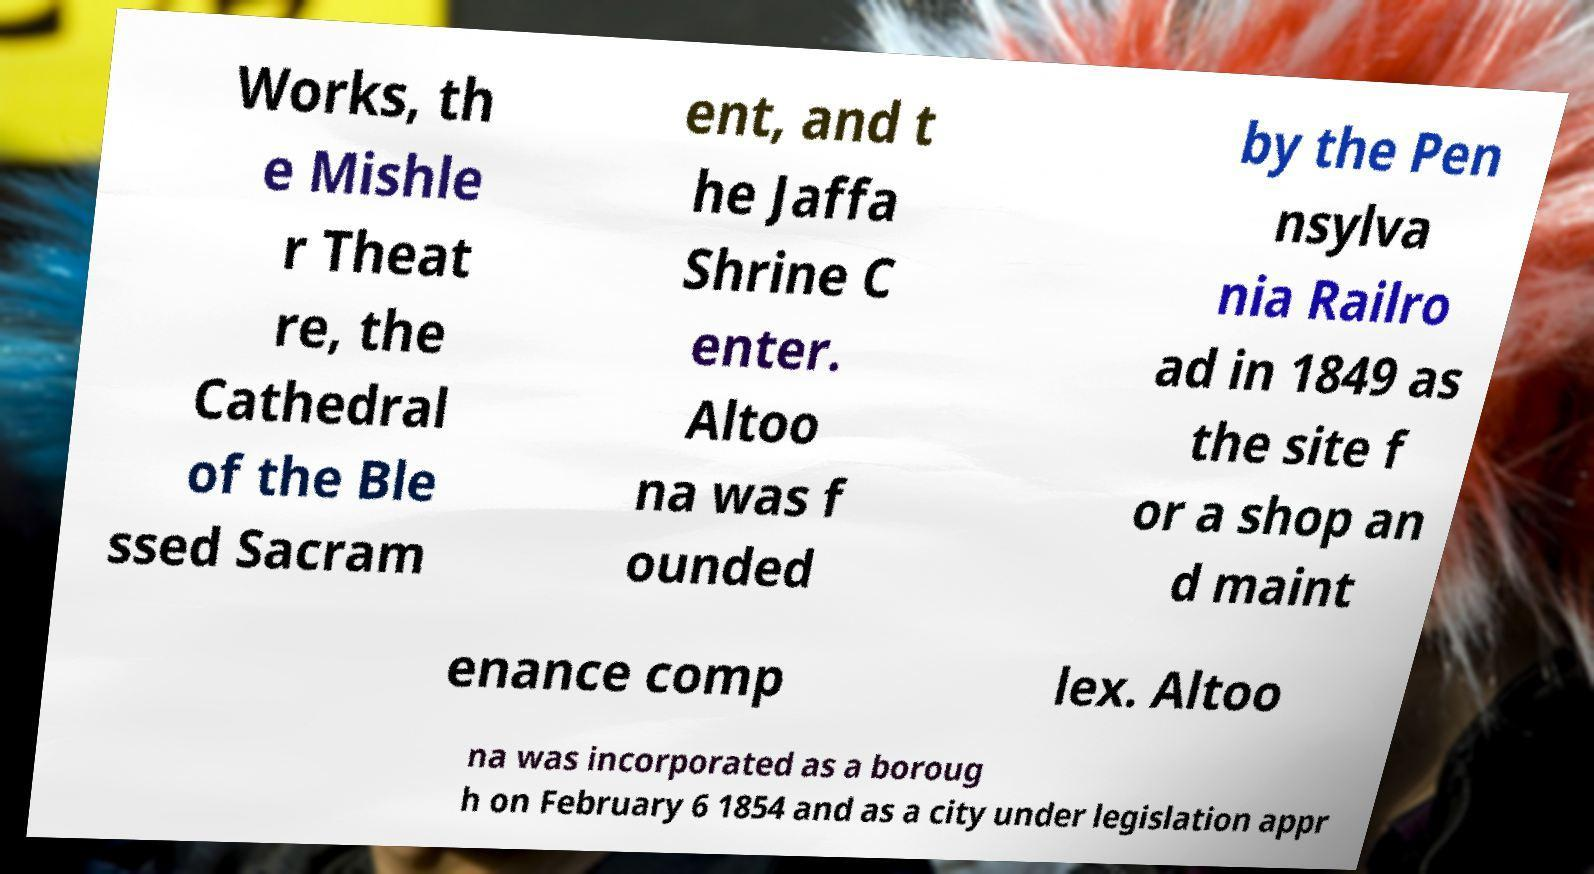For documentation purposes, I need the text within this image transcribed. Could you provide that? Works, th e Mishle r Theat re, the Cathedral of the Ble ssed Sacram ent, and t he Jaffa Shrine C enter. Altoo na was f ounded by the Pen nsylva nia Railro ad in 1849 as the site f or a shop an d maint enance comp lex. Altoo na was incorporated as a boroug h on February 6 1854 and as a city under legislation appr 